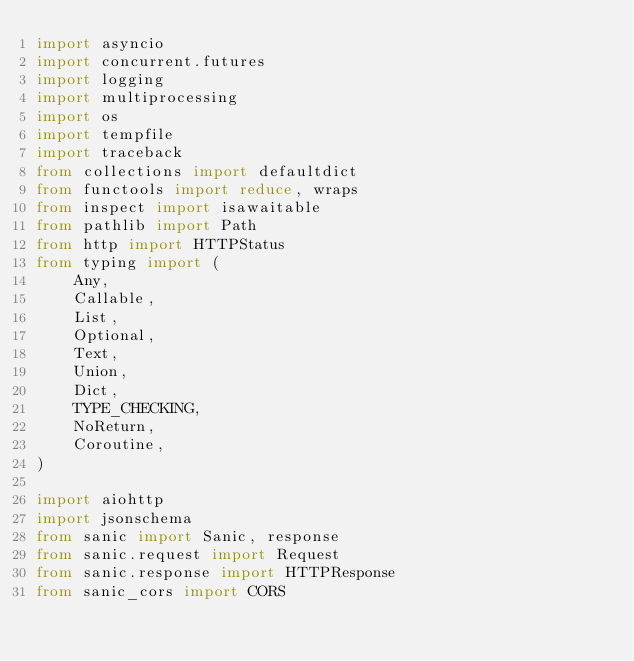Convert code to text. <code><loc_0><loc_0><loc_500><loc_500><_Python_>import asyncio
import concurrent.futures
import logging
import multiprocessing
import os
import tempfile
import traceback
from collections import defaultdict
from functools import reduce, wraps
from inspect import isawaitable
from pathlib import Path
from http import HTTPStatus
from typing import (
    Any,
    Callable,
    List,
    Optional,
    Text,
    Union,
    Dict,
    TYPE_CHECKING,
    NoReturn,
    Coroutine,
)

import aiohttp
import jsonschema
from sanic import Sanic, response
from sanic.request import Request
from sanic.response import HTTPResponse
from sanic_cors import CORS</code> 